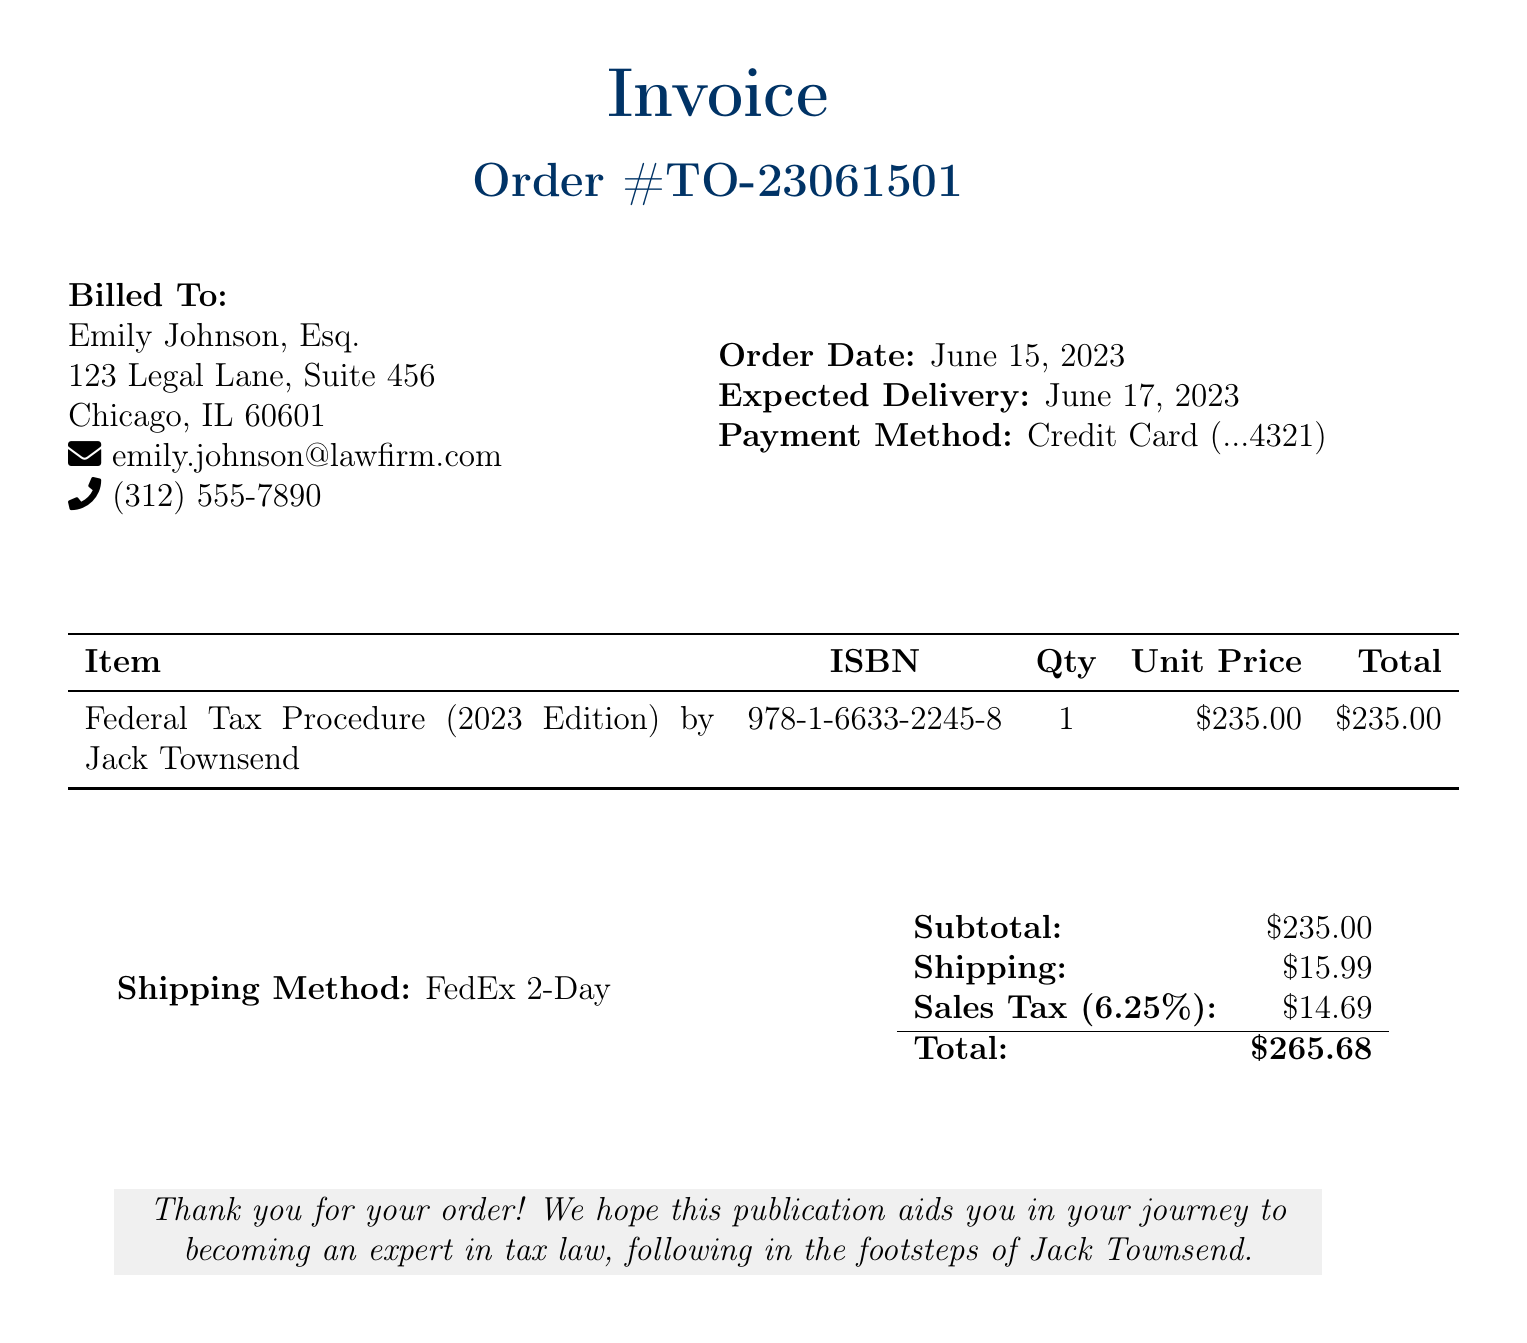What is the order number? The order number is clearly stated in the document as Order #TO-23061501.
Answer: Order #TO-23061501 Who is the billed to? The document specifies that Emily Johnson, Esq. is the billed recipient.
Answer: Emily Johnson, Esq What is the expected delivery date? The expected delivery date provided in the document is June 17, 2023.
Answer: June 17, 2023 What is the unit price of the publication? The unit price for the Federal Tax Procedure (2023 Edition) is listed as $235.00.
Answer: $235.00 What is the subtotal amount? The subtotal amount of the order, before any additional charges, is mentioned as $235.00.
Answer: $235.00 How much is the sales tax? The sales tax is indicated in the document as $14.69.
Answer: $14.69 What shipping method is used? The shipping method mentioned in the bill is FedEx 2-Day.
Answer: FedEx 2-Day What is the total amount due? The total amount due, as calculated in the document, is $265.68.
Answer: $265.68 What is the shipping cost? The cost for shipping included in the bill is $15.99.
Answer: $15.99 